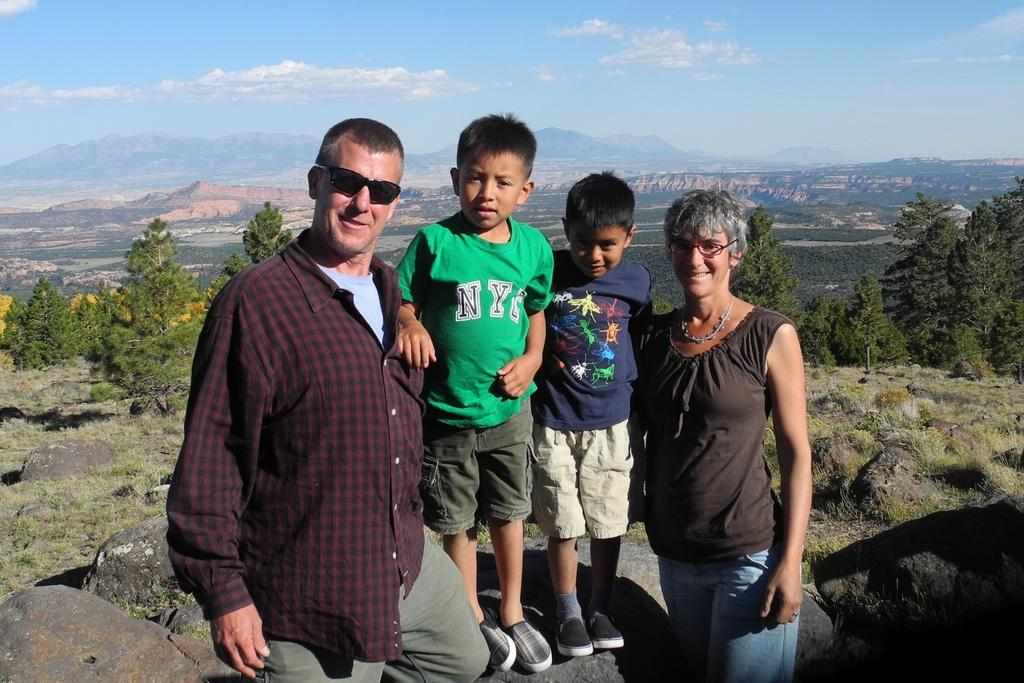What can be seen in the image? There are people standing in the image. Can you describe the children in the image? Children are standing on a rock in the image. What type of natural environment is visible in the image? There are trees and hills visible in the image. What type of club is the children using to learn the new system in the image? There is no club, learning, or system present in the image; it features people standing in a natural environment with trees and hills. 